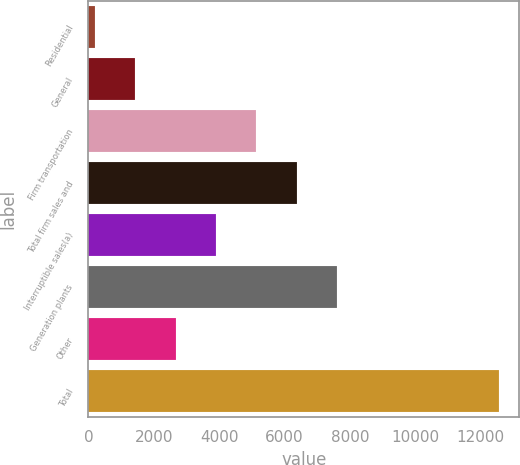Convert chart to OTSL. <chart><loc_0><loc_0><loc_500><loc_500><bar_chart><fcel>Residential<fcel>General<fcel>Firm transportation<fcel>Total firm sales and<fcel>Interruptible sales(a)<fcel>Generation plants<fcel>Other<fcel>Total<nl><fcel>197<fcel>1432.3<fcel>5138.2<fcel>6373.5<fcel>3902.9<fcel>7608.8<fcel>2667.6<fcel>12550<nl></chart> 